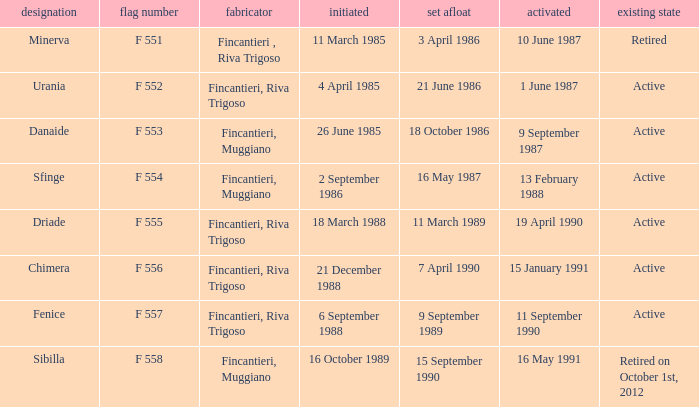What builder launched the name minerva 3 April 1986. 